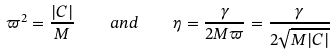Convert formula to latex. <formula><loc_0><loc_0><loc_500><loc_500>\varpi ^ { 2 } = \frac { | C | } { M } \quad a n d \quad \eta = \frac { \gamma } { 2 M \varpi } = \frac { \gamma } { 2 \sqrt { M | C | } }</formula> 